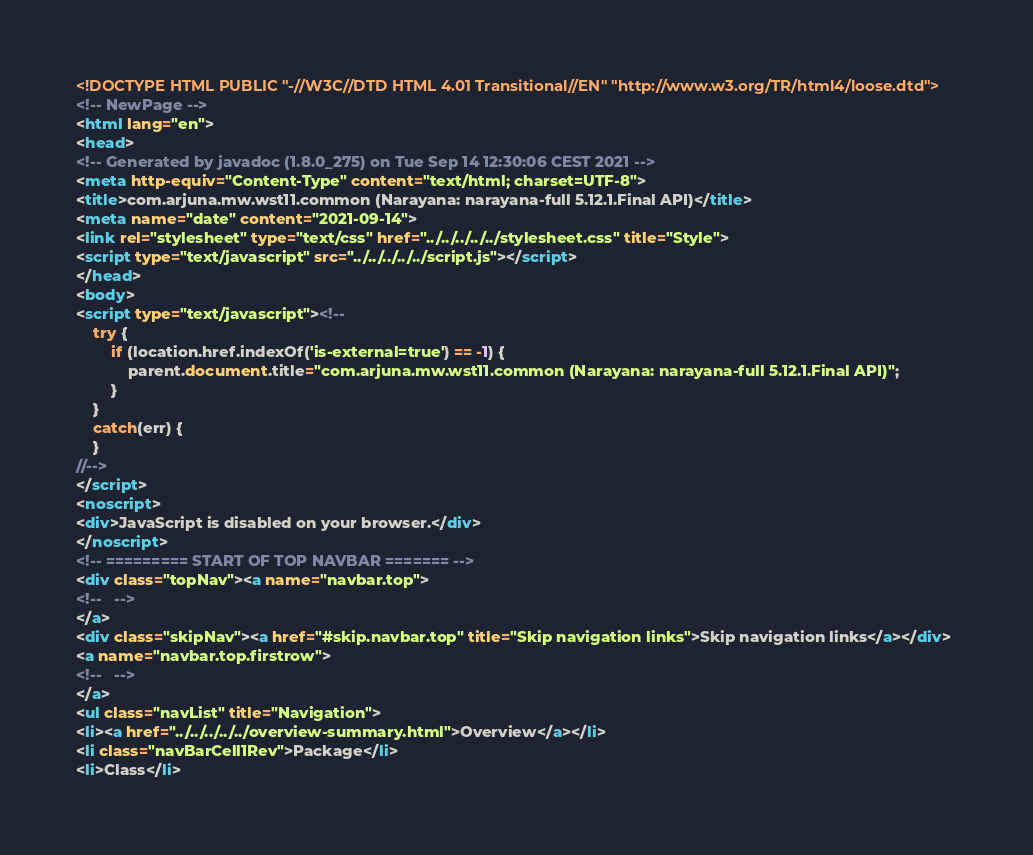Convert code to text. <code><loc_0><loc_0><loc_500><loc_500><_HTML_><!DOCTYPE HTML PUBLIC "-//W3C//DTD HTML 4.01 Transitional//EN" "http://www.w3.org/TR/html4/loose.dtd">
<!-- NewPage -->
<html lang="en">
<head>
<!-- Generated by javadoc (1.8.0_275) on Tue Sep 14 12:30:06 CEST 2021 -->
<meta http-equiv="Content-Type" content="text/html; charset=UTF-8">
<title>com.arjuna.mw.wst11.common (Narayana: narayana-full 5.12.1.Final API)</title>
<meta name="date" content="2021-09-14">
<link rel="stylesheet" type="text/css" href="../../../../../stylesheet.css" title="Style">
<script type="text/javascript" src="../../../../../script.js"></script>
</head>
<body>
<script type="text/javascript"><!--
    try {
        if (location.href.indexOf('is-external=true') == -1) {
            parent.document.title="com.arjuna.mw.wst11.common (Narayana: narayana-full 5.12.1.Final API)";
        }
    }
    catch(err) {
    }
//-->
</script>
<noscript>
<div>JavaScript is disabled on your browser.</div>
</noscript>
<!-- ========= START OF TOP NAVBAR ======= -->
<div class="topNav"><a name="navbar.top">
<!--   -->
</a>
<div class="skipNav"><a href="#skip.navbar.top" title="Skip navigation links">Skip navigation links</a></div>
<a name="navbar.top.firstrow">
<!--   -->
</a>
<ul class="navList" title="Navigation">
<li><a href="../../../../../overview-summary.html">Overview</a></li>
<li class="navBarCell1Rev">Package</li>
<li>Class</li></code> 